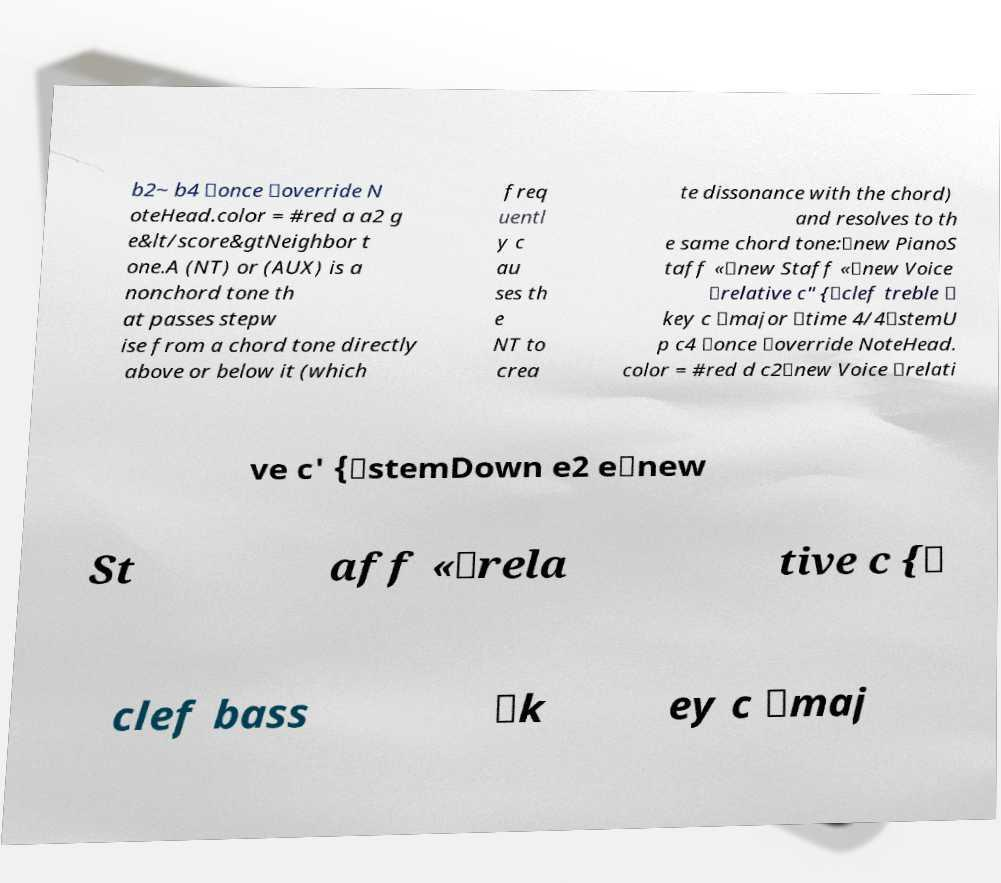Could you assist in decoding the text presented in this image and type it out clearly? b2~ b4 \once \override N oteHead.color = #red a a2 g e&lt/score&gtNeighbor t one.A (NT) or (AUX) is a nonchord tone th at passes stepw ise from a chord tone directly above or below it (which freq uentl y c au ses th e NT to crea te dissonance with the chord) and resolves to th e same chord tone:\new PianoS taff «\new Staff «\new Voice \relative c" {\clef treble \ key c \major \time 4/4\stemU p c4 \once \override NoteHead. color = #red d c2\new Voice \relati ve c' {\stemDown e2 e\new St aff «\rela tive c {\ clef bass \k ey c \maj 